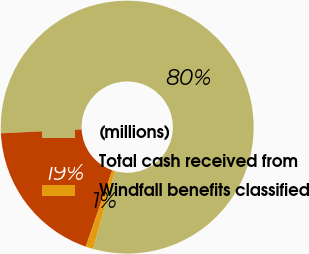Convert chart to OTSL. <chart><loc_0><loc_0><loc_500><loc_500><pie_chart><fcel>(millions)<fcel>Total cash received from<fcel>Windfall benefits classified<nl><fcel>80.14%<fcel>18.91%<fcel>0.96%<nl></chart> 